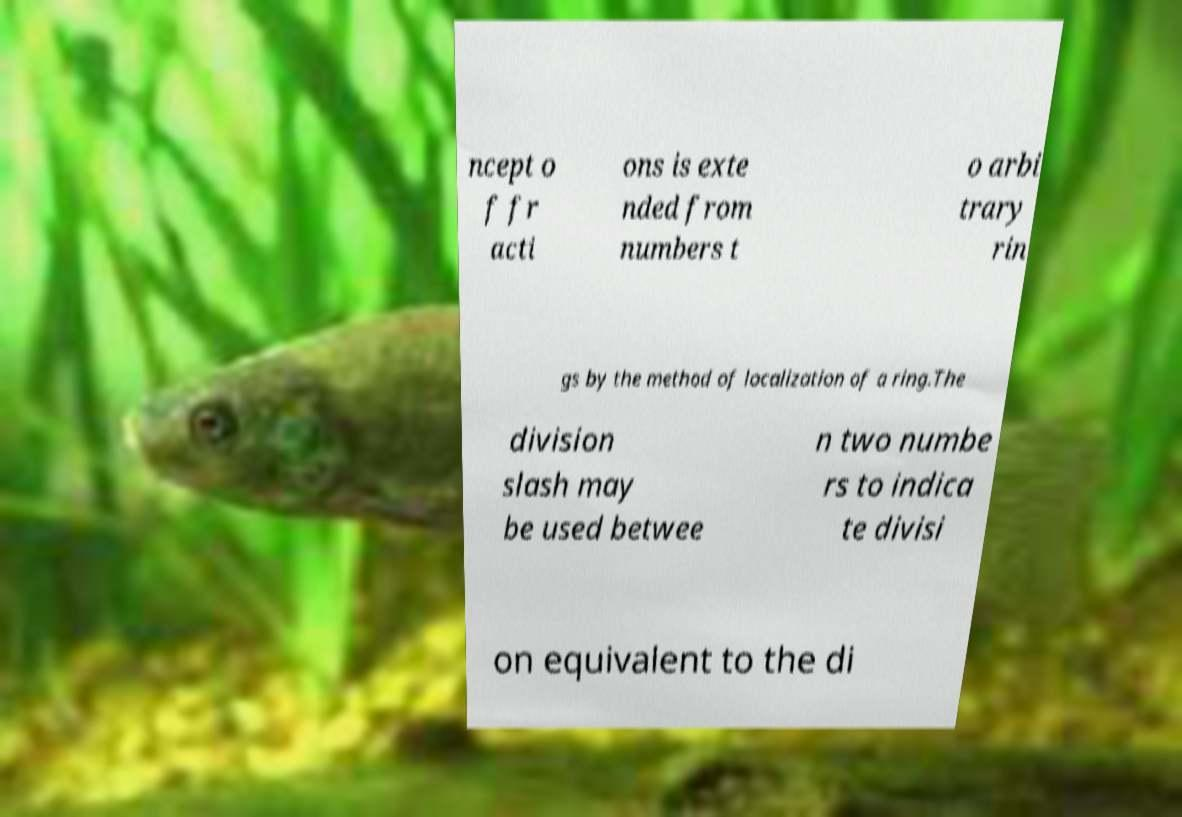Could you assist in decoding the text presented in this image and type it out clearly? ncept o f fr acti ons is exte nded from numbers t o arbi trary rin gs by the method of localization of a ring.The division slash may be used betwee n two numbe rs to indica te divisi on equivalent to the di 